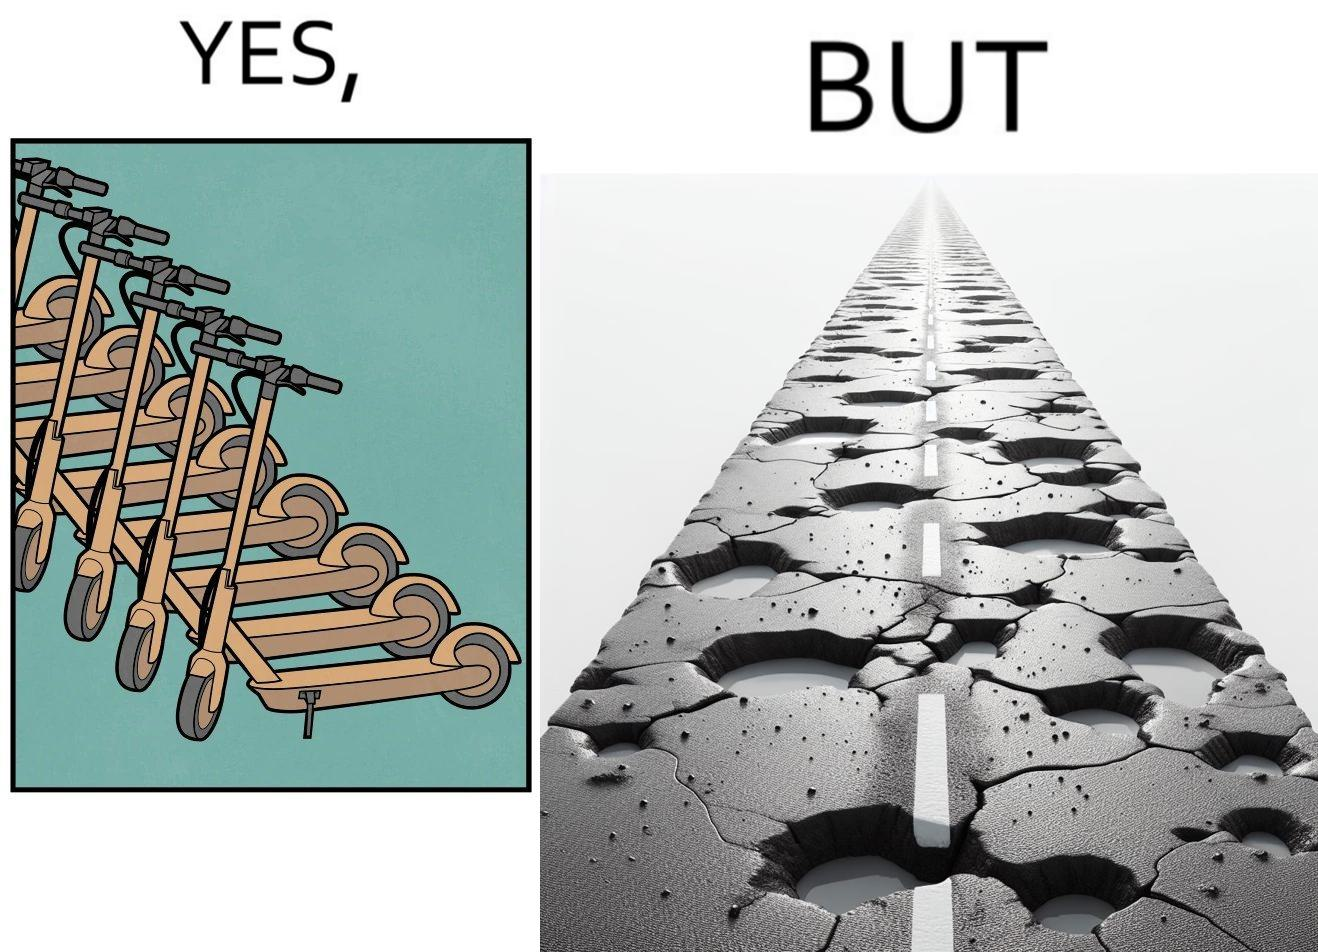Compare the left and right sides of this image. In the left part of the image: many skateboard scooters parked together In the right part of the image: a straight road with many potholes 